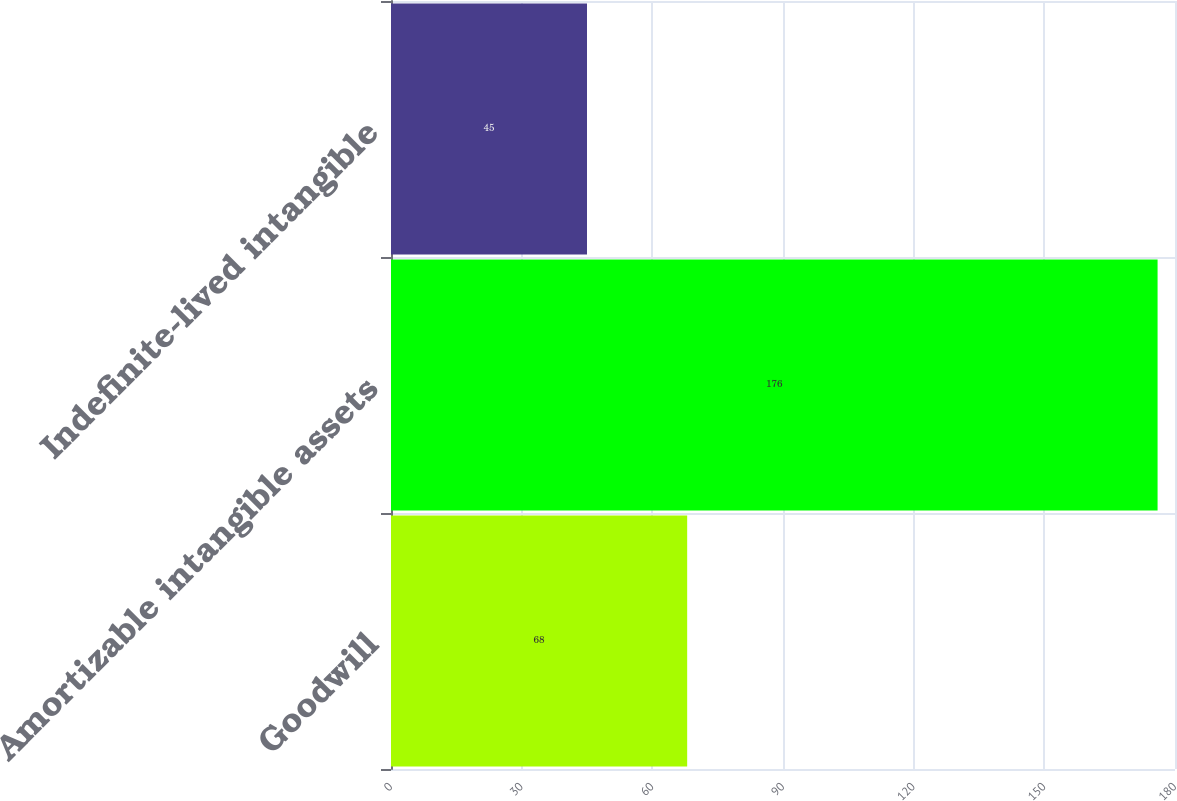Convert chart to OTSL. <chart><loc_0><loc_0><loc_500><loc_500><bar_chart><fcel>Goodwill<fcel>Amortizable intangible assets<fcel>Indefinite-lived intangible<nl><fcel>68<fcel>176<fcel>45<nl></chart> 